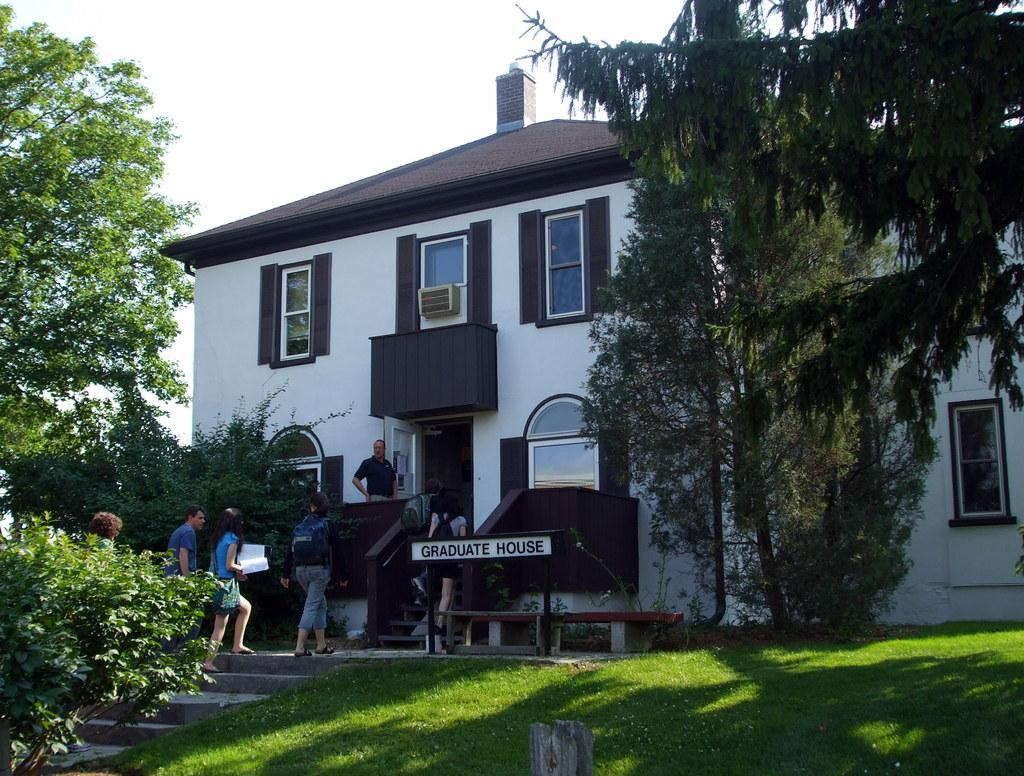What type of building is shown in the picture? There is a graduation house in the picture. What are the people inside the building doing? Students are moving inside the house. What can be seen in front of the house? There are many trees and a garden in front of the house. What type of office is located in the garden in front of the house? There is no office mentioned or visible in the image; it only shows a graduation house with students moving inside and a garden with trees in front. 